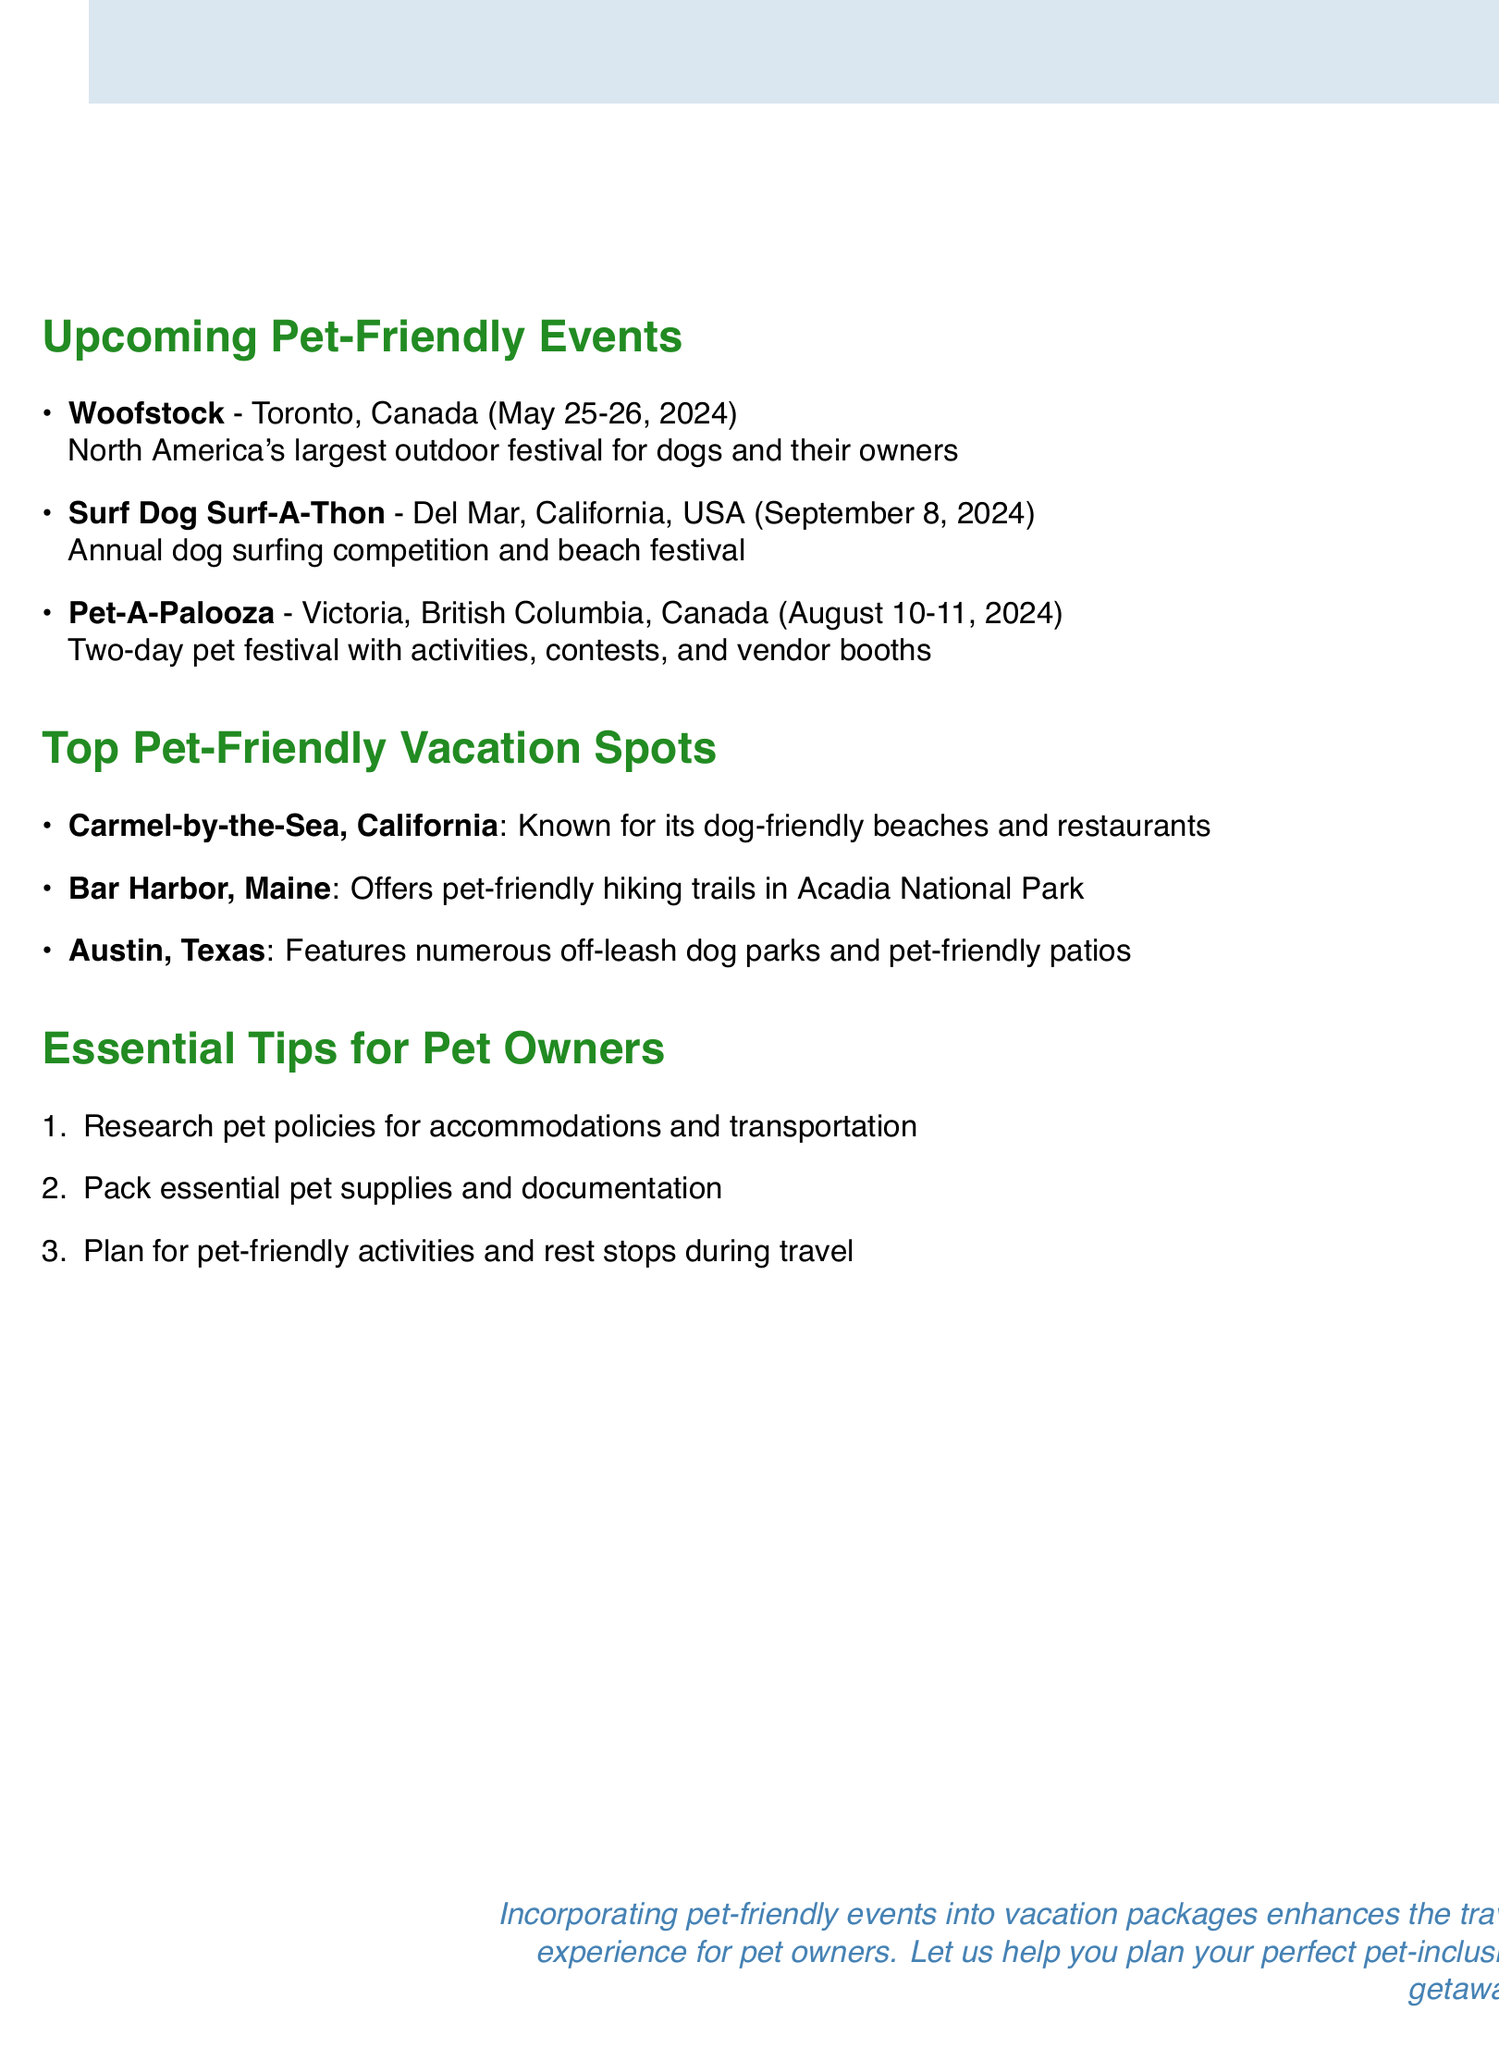What is the name of North America's largest outdoor festival for dogs? The document states that Woofstock is North America's largest outdoor festival for dogs and their owners.
Answer: Woofstock When is the Surf Dog Surf-A-Thon scheduled? The document lists the date for the Surf Dog Surf-A-Thon as September 8, 2024.
Answer: September 8, 2024 Which Canadian city hosts Pet-A-Palooza? According to the document, Pet-A-Palooza takes place in Victoria, British Columbia, Canada.
Answer: Victoria, British Columbia What main highlight is associated with Carmel-by-the-Sea? The document highlights that Carmel-by-the-Sea is known for its dog-friendly beaches and restaurants.
Answer: Dog-friendly beaches and restaurants How many essential tips for pet owners are mentioned? The document lists three essential tips for pet owners.
Answer: Three What type of event is the Surf Dog Surf-A-Thon? The document describes the Surf Dog Surf-A-Thon as an annual dog surfing competition and beach festival.
Answer: Dog surfing competition and beach festival Which pet-friendly destination offers hiking trails? The document states that Bar Harbor, Maine offers pet-friendly hiking trails in Acadia National Park.
Answer: Bar Harbor, Maine What is suggested to research before traveling with a pet? One of the essential tips in the document suggests researching pet policies for accommodations and transportation.
Answer: Pet policies What do the authors suggest enhances the travel experience for pet owners? The conclusion of the document mentions that incorporating pet-friendly events into vacation packages enhances the travel experience for pet owners.
Answer: Incorporating pet-friendly events 